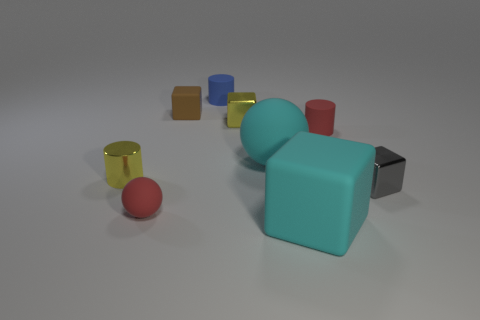How many other objects are there of the same material as the red cylinder? Upon reviewing the image, there are five other objects that appear to be made of the same smooth and shiny material as the red cylinder. These include one yellow cylinder, one blue cube, one orange cube, one aqua cube, and one gray cube. The red sphere does not appear to have the same reflective surface and thus may not be made of the same material. 